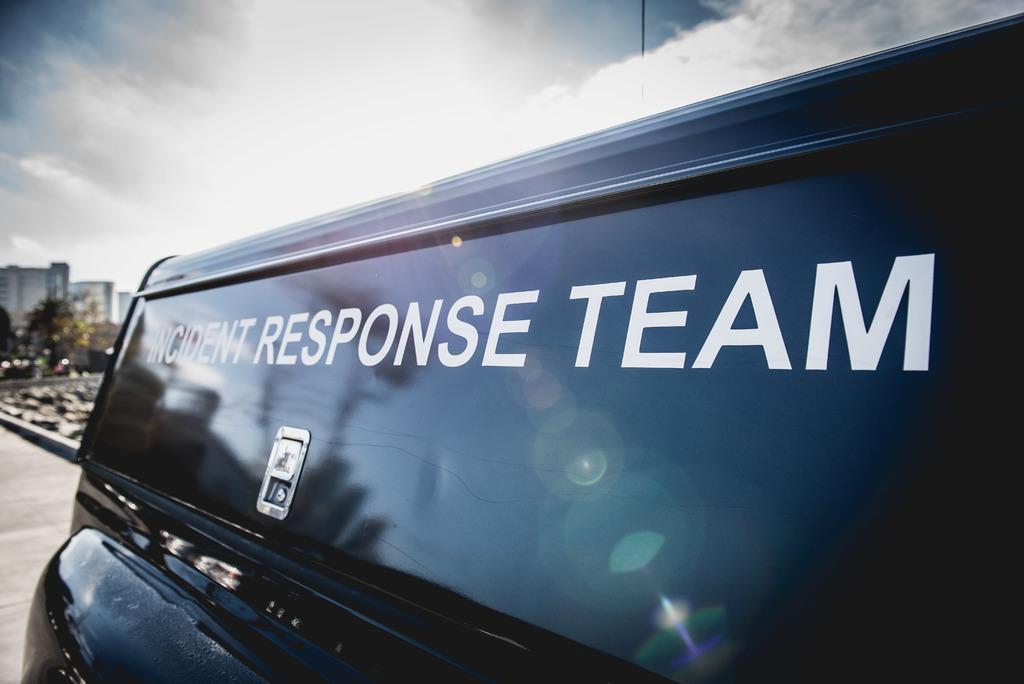Please provide a concise description of this image. In this image we can see a vehicle and in the background, we can see some buildings, trees and sky with clouds. 